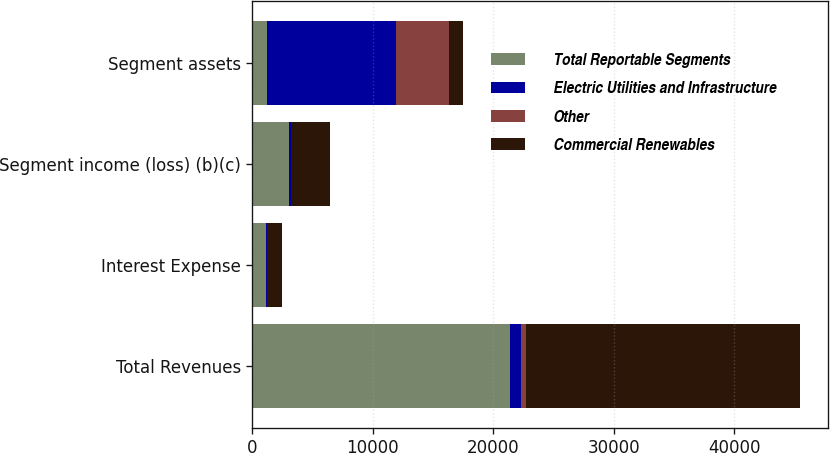<chart> <loc_0><loc_0><loc_500><loc_500><stacked_bar_chart><ecel><fcel>Total Revenues<fcel>Interest Expense<fcel>Segment income (loss) (b)(c)<fcel>Segment assets<nl><fcel>Total Reportable Segments<fcel>21366<fcel>1136<fcel>3040<fcel>1185.5<nl><fcel>Electric Utilities and Infrastructure<fcel>901<fcel>46<fcel>152<fcel>10760<nl><fcel>Other<fcel>484<fcel>53<fcel>23<fcel>4377<nl><fcel>Commercial Renewables<fcel>22751<fcel>1235<fcel>3215<fcel>1185.5<nl></chart> 